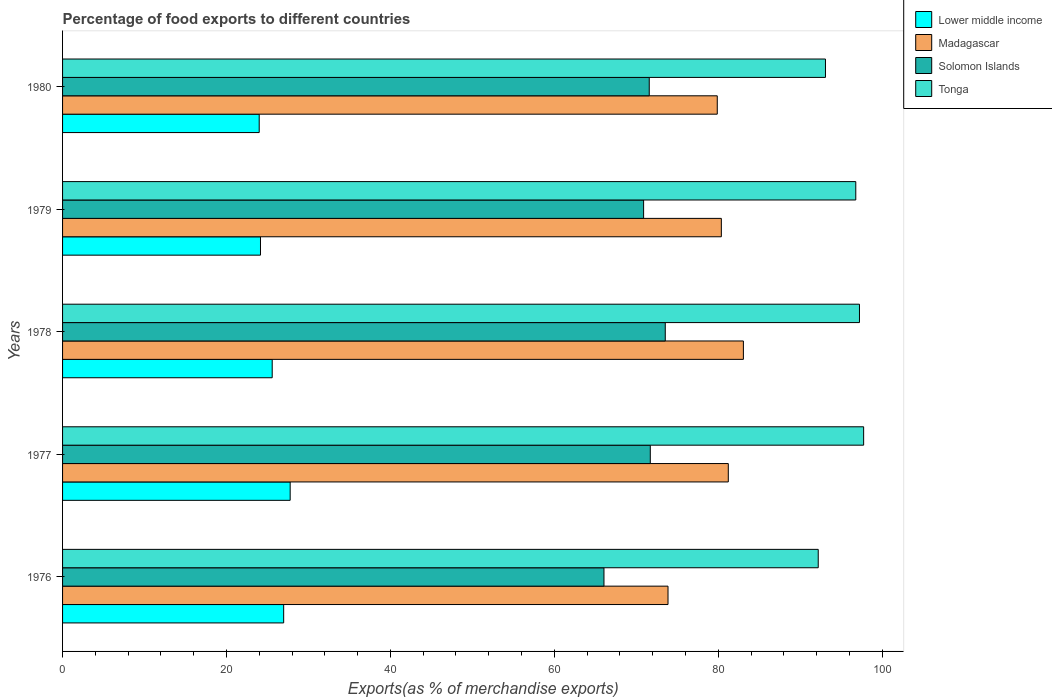How many different coloured bars are there?
Your response must be concise. 4. Are the number of bars per tick equal to the number of legend labels?
Keep it short and to the point. Yes. What is the label of the 2nd group of bars from the top?
Your answer should be very brief. 1979. What is the percentage of exports to different countries in Tonga in 1976?
Provide a succinct answer. 92.21. Across all years, what is the maximum percentage of exports to different countries in Lower middle income?
Offer a terse response. 27.77. Across all years, what is the minimum percentage of exports to different countries in Lower middle income?
Your answer should be compact. 23.99. In which year was the percentage of exports to different countries in Lower middle income minimum?
Offer a terse response. 1980. What is the total percentage of exports to different countries in Madagascar in the graph?
Offer a very short reply. 398.44. What is the difference between the percentage of exports to different countries in Madagascar in 1976 and that in 1980?
Offer a very short reply. -6.01. What is the difference between the percentage of exports to different countries in Lower middle income in 1980 and the percentage of exports to different countries in Madagascar in 1976?
Keep it short and to the point. -49.88. What is the average percentage of exports to different countries in Solomon Islands per year?
Ensure brevity in your answer.  70.76. In the year 1979, what is the difference between the percentage of exports to different countries in Madagascar and percentage of exports to different countries in Tonga?
Your response must be concise. -16.4. What is the ratio of the percentage of exports to different countries in Tonga in 1976 to that in 1977?
Your answer should be compact. 0.94. Is the percentage of exports to different countries in Lower middle income in 1979 less than that in 1980?
Offer a terse response. No. Is the difference between the percentage of exports to different countries in Madagascar in 1977 and 1980 greater than the difference between the percentage of exports to different countries in Tonga in 1977 and 1980?
Make the answer very short. No. What is the difference between the highest and the second highest percentage of exports to different countries in Tonga?
Keep it short and to the point. 0.51. What is the difference between the highest and the lowest percentage of exports to different countries in Solomon Islands?
Offer a terse response. 7.48. In how many years, is the percentage of exports to different countries in Solomon Islands greater than the average percentage of exports to different countries in Solomon Islands taken over all years?
Your answer should be very brief. 4. Is the sum of the percentage of exports to different countries in Madagascar in 1977 and 1980 greater than the maximum percentage of exports to different countries in Solomon Islands across all years?
Offer a very short reply. Yes. Is it the case that in every year, the sum of the percentage of exports to different countries in Tonga and percentage of exports to different countries in Solomon Islands is greater than the sum of percentage of exports to different countries in Madagascar and percentage of exports to different countries in Lower middle income?
Provide a short and direct response. No. What does the 1st bar from the top in 1980 represents?
Your response must be concise. Tonga. What does the 3rd bar from the bottom in 1976 represents?
Your response must be concise. Solomon Islands. Is it the case that in every year, the sum of the percentage of exports to different countries in Solomon Islands and percentage of exports to different countries in Lower middle income is greater than the percentage of exports to different countries in Tonga?
Your answer should be compact. No. Are all the bars in the graph horizontal?
Your answer should be compact. Yes. What is the difference between two consecutive major ticks on the X-axis?
Provide a short and direct response. 20. Does the graph contain any zero values?
Ensure brevity in your answer.  No. Does the graph contain grids?
Your response must be concise. No. How are the legend labels stacked?
Give a very brief answer. Vertical. What is the title of the graph?
Make the answer very short. Percentage of food exports to different countries. Does "Andorra" appear as one of the legend labels in the graph?
Your answer should be very brief. No. What is the label or title of the X-axis?
Make the answer very short. Exports(as % of merchandise exports). What is the label or title of the Y-axis?
Provide a succinct answer. Years. What is the Exports(as % of merchandise exports) of Lower middle income in 1976?
Your answer should be very brief. 26.98. What is the Exports(as % of merchandise exports) of Madagascar in 1976?
Provide a short and direct response. 73.87. What is the Exports(as % of merchandise exports) in Solomon Islands in 1976?
Your response must be concise. 66.06. What is the Exports(as % of merchandise exports) in Tonga in 1976?
Your answer should be very brief. 92.21. What is the Exports(as % of merchandise exports) in Lower middle income in 1977?
Keep it short and to the point. 27.77. What is the Exports(as % of merchandise exports) in Madagascar in 1977?
Make the answer very short. 81.23. What is the Exports(as % of merchandise exports) of Solomon Islands in 1977?
Your response must be concise. 71.71. What is the Exports(as % of merchandise exports) in Tonga in 1977?
Ensure brevity in your answer.  97.75. What is the Exports(as % of merchandise exports) in Lower middle income in 1978?
Offer a terse response. 25.58. What is the Exports(as % of merchandise exports) in Madagascar in 1978?
Provide a succinct answer. 83.07. What is the Exports(as % of merchandise exports) of Solomon Islands in 1978?
Offer a very short reply. 73.54. What is the Exports(as % of merchandise exports) in Tonga in 1978?
Give a very brief answer. 97.24. What is the Exports(as % of merchandise exports) of Lower middle income in 1979?
Ensure brevity in your answer.  24.15. What is the Exports(as % of merchandise exports) of Madagascar in 1979?
Ensure brevity in your answer.  80.38. What is the Exports(as % of merchandise exports) of Solomon Islands in 1979?
Offer a very short reply. 70.9. What is the Exports(as % of merchandise exports) in Tonga in 1979?
Make the answer very short. 96.79. What is the Exports(as % of merchandise exports) in Lower middle income in 1980?
Your answer should be compact. 23.99. What is the Exports(as % of merchandise exports) of Madagascar in 1980?
Your response must be concise. 79.89. What is the Exports(as % of merchandise exports) of Solomon Islands in 1980?
Your answer should be compact. 71.59. What is the Exports(as % of merchandise exports) of Tonga in 1980?
Your answer should be compact. 93.09. Across all years, what is the maximum Exports(as % of merchandise exports) in Lower middle income?
Make the answer very short. 27.77. Across all years, what is the maximum Exports(as % of merchandise exports) in Madagascar?
Keep it short and to the point. 83.07. Across all years, what is the maximum Exports(as % of merchandise exports) of Solomon Islands?
Your response must be concise. 73.54. Across all years, what is the maximum Exports(as % of merchandise exports) of Tonga?
Provide a succinct answer. 97.75. Across all years, what is the minimum Exports(as % of merchandise exports) in Lower middle income?
Your response must be concise. 23.99. Across all years, what is the minimum Exports(as % of merchandise exports) of Madagascar?
Give a very brief answer. 73.87. Across all years, what is the minimum Exports(as % of merchandise exports) in Solomon Islands?
Offer a terse response. 66.06. Across all years, what is the minimum Exports(as % of merchandise exports) in Tonga?
Your response must be concise. 92.21. What is the total Exports(as % of merchandise exports) of Lower middle income in the graph?
Offer a very short reply. 128.47. What is the total Exports(as % of merchandise exports) in Madagascar in the graph?
Your answer should be compact. 398.44. What is the total Exports(as % of merchandise exports) of Solomon Islands in the graph?
Your response must be concise. 353.8. What is the total Exports(as % of merchandise exports) in Tonga in the graph?
Provide a short and direct response. 477.06. What is the difference between the Exports(as % of merchandise exports) in Lower middle income in 1976 and that in 1977?
Ensure brevity in your answer.  -0.79. What is the difference between the Exports(as % of merchandise exports) in Madagascar in 1976 and that in 1977?
Offer a terse response. -7.36. What is the difference between the Exports(as % of merchandise exports) of Solomon Islands in 1976 and that in 1977?
Keep it short and to the point. -5.65. What is the difference between the Exports(as % of merchandise exports) in Tonga in 1976 and that in 1977?
Provide a succinct answer. -5.54. What is the difference between the Exports(as % of merchandise exports) of Lower middle income in 1976 and that in 1978?
Offer a very short reply. 1.4. What is the difference between the Exports(as % of merchandise exports) of Madagascar in 1976 and that in 1978?
Your response must be concise. -9.2. What is the difference between the Exports(as % of merchandise exports) in Solomon Islands in 1976 and that in 1978?
Provide a short and direct response. -7.48. What is the difference between the Exports(as % of merchandise exports) of Tonga in 1976 and that in 1978?
Give a very brief answer. -5.03. What is the difference between the Exports(as % of merchandise exports) of Lower middle income in 1976 and that in 1979?
Offer a terse response. 2.83. What is the difference between the Exports(as % of merchandise exports) of Madagascar in 1976 and that in 1979?
Provide a short and direct response. -6.51. What is the difference between the Exports(as % of merchandise exports) of Solomon Islands in 1976 and that in 1979?
Give a very brief answer. -4.84. What is the difference between the Exports(as % of merchandise exports) in Tonga in 1976 and that in 1979?
Keep it short and to the point. -4.58. What is the difference between the Exports(as % of merchandise exports) in Lower middle income in 1976 and that in 1980?
Offer a terse response. 2.99. What is the difference between the Exports(as % of merchandise exports) of Madagascar in 1976 and that in 1980?
Your response must be concise. -6.01. What is the difference between the Exports(as % of merchandise exports) in Solomon Islands in 1976 and that in 1980?
Your answer should be very brief. -5.52. What is the difference between the Exports(as % of merchandise exports) of Tonga in 1976 and that in 1980?
Provide a succinct answer. -0.88. What is the difference between the Exports(as % of merchandise exports) of Lower middle income in 1977 and that in 1978?
Make the answer very short. 2.19. What is the difference between the Exports(as % of merchandise exports) in Madagascar in 1977 and that in 1978?
Make the answer very short. -1.84. What is the difference between the Exports(as % of merchandise exports) in Solomon Islands in 1977 and that in 1978?
Keep it short and to the point. -1.83. What is the difference between the Exports(as % of merchandise exports) in Tonga in 1977 and that in 1978?
Offer a very short reply. 0.51. What is the difference between the Exports(as % of merchandise exports) of Lower middle income in 1977 and that in 1979?
Give a very brief answer. 3.62. What is the difference between the Exports(as % of merchandise exports) in Madagascar in 1977 and that in 1979?
Provide a succinct answer. 0.85. What is the difference between the Exports(as % of merchandise exports) of Solomon Islands in 1977 and that in 1979?
Offer a very short reply. 0.82. What is the difference between the Exports(as % of merchandise exports) of Tonga in 1977 and that in 1979?
Ensure brevity in your answer.  0.96. What is the difference between the Exports(as % of merchandise exports) of Lower middle income in 1977 and that in 1980?
Ensure brevity in your answer.  3.78. What is the difference between the Exports(as % of merchandise exports) of Madagascar in 1977 and that in 1980?
Your answer should be compact. 1.34. What is the difference between the Exports(as % of merchandise exports) of Solomon Islands in 1977 and that in 1980?
Your answer should be compact. 0.13. What is the difference between the Exports(as % of merchandise exports) of Tonga in 1977 and that in 1980?
Your response must be concise. 4.66. What is the difference between the Exports(as % of merchandise exports) of Lower middle income in 1978 and that in 1979?
Your answer should be very brief. 1.43. What is the difference between the Exports(as % of merchandise exports) in Madagascar in 1978 and that in 1979?
Keep it short and to the point. 2.69. What is the difference between the Exports(as % of merchandise exports) of Solomon Islands in 1978 and that in 1979?
Your answer should be very brief. 2.64. What is the difference between the Exports(as % of merchandise exports) in Tonga in 1978 and that in 1979?
Provide a succinct answer. 0.45. What is the difference between the Exports(as % of merchandise exports) of Lower middle income in 1978 and that in 1980?
Your answer should be very brief. 1.59. What is the difference between the Exports(as % of merchandise exports) in Madagascar in 1978 and that in 1980?
Give a very brief answer. 3.19. What is the difference between the Exports(as % of merchandise exports) of Solomon Islands in 1978 and that in 1980?
Your answer should be compact. 1.95. What is the difference between the Exports(as % of merchandise exports) of Tonga in 1978 and that in 1980?
Your answer should be compact. 4.15. What is the difference between the Exports(as % of merchandise exports) in Lower middle income in 1979 and that in 1980?
Ensure brevity in your answer.  0.16. What is the difference between the Exports(as % of merchandise exports) of Madagascar in 1979 and that in 1980?
Offer a very short reply. 0.5. What is the difference between the Exports(as % of merchandise exports) of Solomon Islands in 1979 and that in 1980?
Ensure brevity in your answer.  -0.69. What is the difference between the Exports(as % of merchandise exports) in Tonga in 1979 and that in 1980?
Offer a very short reply. 3.7. What is the difference between the Exports(as % of merchandise exports) of Lower middle income in 1976 and the Exports(as % of merchandise exports) of Madagascar in 1977?
Give a very brief answer. -54.25. What is the difference between the Exports(as % of merchandise exports) in Lower middle income in 1976 and the Exports(as % of merchandise exports) in Solomon Islands in 1977?
Give a very brief answer. -44.73. What is the difference between the Exports(as % of merchandise exports) of Lower middle income in 1976 and the Exports(as % of merchandise exports) of Tonga in 1977?
Offer a very short reply. -70.77. What is the difference between the Exports(as % of merchandise exports) in Madagascar in 1976 and the Exports(as % of merchandise exports) in Solomon Islands in 1977?
Your answer should be very brief. 2.16. What is the difference between the Exports(as % of merchandise exports) of Madagascar in 1976 and the Exports(as % of merchandise exports) of Tonga in 1977?
Your answer should be compact. -23.87. What is the difference between the Exports(as % of merchandise exports) in Solomon Islands in 1976 and the Exports(as % of merchandise exports) in Tonga in 1977?
Make the answer very short. -31.68. What is the difference between the Exports(as % of merchandise exports) in Lower middle income in 1976 and the Exports(as % of merchandise exports) in Madagascar in 1978?
Give a very brief answer. -56.09. What is the difference between the Exports(as % of merchandise exports) of Lower middle income in 1976 and the Exports(as % of merchandise exports) of Solomon Islands in 1978?
Provide a short and direct response. -46.56. What is the difference between the Exports(as % of merchandise exports) of Lower middle income in 1976 and the Exports(as % of merchandise exports) of Tonga in 1978?
Your answer should be compact. -70.26. What is the difference between the Exports(as % of merchandise exports) of Madagascar in 1976 and the Exports(as % of merchandise exports) of Solomon Islands in 1978?
Provide a short and direct response. 0.34. What is the difference between the Exports(as % of merchandise exports) in Madagascar in 1976 and the Exports(as % of merchandise exports) in Tonga in 1978?
Your answer should be compact. -23.36. What is the difference between the Exports(as % of merchandise exports) of Solomon Islands in 1976 and the Exports(as % of merchandise exports) of Tonga in 1978?
Your answer should be very brief. -31.18. What is the difference between the Exports(as % of merchandise exports) of Lower middle income in 1976 and the Exports(as % of merchandise exports) of Madagascar in 1979?
Ensure brevity in your answer.  -53.4. What is the difference between the Exports(as % of merchandise exports) in Lower middle income in 1976 and the Exports(as % of merchandise exports) in Solomon Islands in 1979?
Provide a short and direct response. -43.92. What is the difference between the Exports(as % of merchandise exports) of Lower middle income in 1976 and the Exports(as % of merchandise exports) of Tonga in 1979?
Give a very brief answer. -69.81. What is the difference between the Exports(as % of merchandise exports) of Madagascar in 1976 and the Exports(as % of merchandise exports) of Solomon Islands in 1979?
Your answer should be compact. 2.98. What is the difference between the Exports(as % of merchandise exports) in Madagascar in 1976 and the Exports(as % of merchandise exports) in Tonga in 1979?
Give a very brief answer. -22.91. What is the difference between the Exports(as % of merchandise exports) in Solomon Islands in 1976 and the Exports(as % of merchandise exports) in Tonga in 1979?
Your answer should be compact. -30.73. What is the difference between the Exports(as % of merchandise exports) in Lower middle income in 1976 and the Exports(as % of merchandise exports) in Madagascar in 1980?
Your answer should be very brief. -52.91. What is the difference between the Exports(as % of merchandise exports) in Lower middle income in 1976 and the Exports(as % of merchandise exports) in Solomon Islands in 1980?
Ensure brevity in your answer.  -44.61. What is the difference between the Exports(as % of merchandise exports) in Lower middle income in 1976 and the Exports(as % of merchandise exports) in Tonga in 1980?
Keep it short and to the point. -66.11. What is the difference between the Exports(as % of merchandise exports) in Madagascar in 1976 and the Exports(as % of merchandise exports) in Solomon Islands in 1980?
Make the answer very short. 2.29. What is the difference between the Exports(as % of merchandise exports) in Madagascar in 1976 and the Exports(as % of merchandise exports) in Tonga in 1980?
Provide a short and direct response. -19.21. What is the difference between the Exports(as % of merchandise exports) in Solomon Islands in 1976 and the Exports(as % of merchandise exports) in Tonga in 1980?
Your response must be concise. -27.03. What is the difference between the Exports(as % of merchandise exports) of Lower middle income in 1977 and the Exports(as % of merchandise exports) of Madagascar in 1978?
Your answer should be compact. -55.3. What is the difference between the Exports(as % of merchandise exports) of Lower middle income in 1977 and the Exports(as % of merchandise exports) of Solomon Islands in 1978?
Provide a short and direct response. -45.77. What is the difference between the Exports(as % of merchandise exports) of Lower middle income in 1977 and the Exports(as % of merchandise exports) of Tonga in 1978?
Provide a short and direct response. -69.46. What is the difference between the Exports(as % of merchandise exports) in Madagascar in 1977 and the Exports(as % of merchandise exports) in Solomon Islands in 1978?
Give a very brief answer. 7.69. What is the difference between the Exports(as % of merchandise exports) of Madagascar in 1977 and the Exports(as % of merchandise exports) of Tonga in 1978?
Give a very brief answer. -16.01. What is the difference between the Exports(as % of merchandise exports) of Solomon Islands in 1977 and the Exports(as % of merchandise exports) of Tonga in 1978?
Offer a terse response. -25.52. What is the difference between the Exports(as % of merchandise exports) of Lower middle income in 1977 and the Exports(as % of merchandise exports) of Madagascar in 1979?
Your response must be concise. -52.61. What is the difference between the Exports(as % of merchandise exports) in Lower middle income in 1977 and the Exports(as % of merchandise exports) in Solomon Islands in 1979?
Offer a very short reply. -43.13. What is the difference between the Exports(as % of merchandise exports) of Lower middle income in 1977 and the Exports(as % of merchandise exports) of Tonga in 1979?
Ensure brevity in your answer.  -69.02. What is the difference between the Exports(as % of merchandise exports) in Madagascar in 1977 and the Exports(as % of merchandise exports) in Solomon Islands in 1979?
Keep it short and to the point. 10.33. What is the difference between the Exports(as % of merchandise exports) of Madagascar in 1977 and the Exports(as % of merchandise exports) of Tonga in 1979?
Your response must be concise. -15.56. What is the difference between the Exports(as % of merchandise exports) of Solomon Islands in 1977 and the Exports(as % of merchandise exports) of Tonga in 1979?
Provide a succinct answer. -25.07. What is the difference between the Exports(as % of merchandise exports) in Lower middle income in 1977 and the Exports(as % of merchandise exports) in Madagascar in 1980?
Provide a succinct answer. -52.11. What is the difference between the Exports(as % of merchandise exports) of Lower middle income in 1977 and the Exports(as % of merchandise exports) of Solomon Islands in 1980?
Your answer should be very brief. -43.81. What is the difference between the Exports(as % of merchandise exports) of Lower middle income in 1977 and the Exports(as % of merchandise exports) of Tonga in 1980?
Give a very brief answer. -65.32. What is the difference between the Exports(as % of merchandise exports) in Madagascar in 1977 and the Exports(as % of merchandise exports) in Solomon Islands in 1980?
Provide a succinct answer. 9.64. What is the difference between the Exports(as % of merchandise exports) in Madagascar in 1977 and the Exports(as % of merchandise exports) in Tonga in 1980?
Make the answer very short. -11.86. What is the difference between the Exports(as % of merchandise exports) of Solomon Islands in 1977 and the Exports(as % of merchandise exports) of Tonga in 1980?
Offer a very short reply. -21.37. What is the difference between the Exports(as % of merchandise exports) of Lower middle income in 1978 and the Exports(as % of merchandise exports) of Madagascar in 1979?
Offer a very short reply. -54.8. What is the difference between the Exports(as % of merchandise exports) in Lower middle income in 1978 and the Exports(as % of merchandise exports) in Solomon Islands in 1979?
Keep it short and to the point. -45.32. What is the difference between the Exports(as % of merchandise exports) in Lower middle income in 1978 and the Exports(as % of merchandise exports) in Tonga in 1979?
Keep it short and to the point. -71.21. What is the difference between the Exports(as % of merchandise exports) of Madagascar in 1978 and the Exports(as % of merchandise exports) of Solomon Islands in 1979?
Offer a very short reply. 12.17. What is the difference between the Exports(as % of merchandise exports) in Madagascar in 1978 and the Exports(as % of merchandise exports) in Tonga in 1979?
Your answer should be compact. -13.71. What is the difference between the Exports(as % of merchandise exports) in Solomon Islands in 1978 and the Exports(as % of merchandise exports) in Tonga in 1979?
Provide a short and direct response. -23.25. What is the difference between the Exports(as % of merchandise exports) in Lower middle income in 1978 and the Exports(as % of merchandise exports) in Madagascar in 1980?
Your answer should be very brief. -54.31. What is the difference between the Exports(as % of merchandise exports) of Lower middle income in 1978 and the Exports(as % of merchandise exports) of Solomon Islands in 1980?
Provide a succinct answer. -46. What is the difference between the Exports(as % of merchandise exports) of Lower middle income in 1978 and the Exports(as % of merchandise exports) of Tonga in 1980?
Your answer should be compact. -67.51. What is the difference between the Exports(as % of merchandise exports) in Madagascar in 1978 and the Exports(as % of merchandise exports) in Solomon Islands in 1980?
Ensure brevity in your answer.  11.49. What is the difference between the Exports(as % of merchandise exports) in Madagascar in 1978 and the Exports(as % of merchandise exports) in Tonga in 1980?
Your answer should be very brief. -10.02. What is the difference between the Exports(as % of merchandise exports) of Solomon Islands in 1978 and the Exports(as % of merchandise exports) of Tonga in 1980?
Keep it short and to the point. -19.55. What is the difference between the Exports(as % of merchandise exports) in Lower middle income in 1979 and the Exports(as % of merchandise exports) in Madagascar in 1980?
Offer a terse response. -55.74. What is the difference between the Exports(as % of merchandise exports) in Lower middle income in 1979 and the Exports(as % of merchandise exports) in Solomon Islands in 1980?
Your answer should be compact. -47.44. What is the difference between the Exports(as % of merchandise exports) of Lower middle income in 1979 and the Exports(as % of merchandise exports) of Tonga in 1980?
Ensure brevity in your answer.  -68.94. What is the difference between the Exports(as % of merchandise exports) of Madagascar in 1979 and the Exports(as % of merchandise exports) of Solomon Islands in 1980?
Your response must be concise. 8.8. What is the difference between the Exports(as % of merchandise exports) of Madagascar in 1979 and the Exports(as % of merchandise exports) of Tonga in 1980?
Give a very brief answer. -12.71. What is the difference between the Exports(as % of merchandise exports) in Solomon Islands in 1979 and the Exports(as % of merchandise exports) in Tonga in 1980?
Your response must be concise. -22.19. What is the average Exports(as % of merchandise exports) in Lower middle income per year?
Your answer should be compact. 25.69. What is the average Exports(as % of merchandise exports) in Madagascar per year?
Your answer should be compact. 79.69. What is the average Exports(as % of merchandise exports) of Solomon Islands per year?
Offer a very short reply. 70.76. What is the average Exports(as % of merchandise exports) of Tonga per year?
Keep it short and to the point. 95.41. In the year 1976, what is the difference between the Exports(as % of merchandise exports) of Lower middle income and Exports(as % of merchandise exports) of Madagascar?
Provide a short and direct response. -46.9. In the year 1976, what is the difference between the Exports(as % of merchandise exports) of Lower middle income and Exports(as % of merchandise exports) of Solomon Islands?
Keep it short and to the point. -39.08. In the year 1976, what is the difference between the Exports(as % of merchandise exports) in Lower middle income and Exports(as % of merchandise exports) in Tonga?
Make the answer very short. -65.23. In the year 1976, what is the difference between the Exports(as % of merchandise exports) of Madagascar and Exports(as % of merchandise exports) of Solomon Islands?
Your response must be concise. 7.81. In the year 1976, what is the difference between the Exports(as % of merchandise exports) of Madagascar and Exports(as % of merchandise exports) of Tonga?
Keep it short and to the point. -18.33. In the year 1976, what is the difference between the Exports(as % of merchandise exports) in Solomon Islands and Exports(as % of merchandise exports) in Tonga?
Your response must be concise. -26.15. In the year 1977, what is the difference between the Exports(as % of merchandise exports) in Lower middle income and Exports(as % of merchandise exports) in Madagascar?
Offer a terse response. -53.46. In the year 1977, what is the difference between the Exports(as % of merchandise exports) in Lower middle income and Exports(as % of merchandise exports) in Solomon Islands?
Your answer should be very brief. -43.94. In the year 1977, what is the difference between the Exports(as % of merchandise exports) of Lower middle income and Exports(as % of merchandise exports) of Tonga?
Provide a succinct answer. -69.97. In the year 1977, what is the difference between the Exports(as % of merchandise exports) in Madagascar and Exports(as % of merchandise exports) in Solomon Islands?
Your response must be concise. 9.52. In the year 1977, what is the difference between the Exports(as % of merchandise exports) in Madagascar and Exports(as % of merchandise exports) in Tonga?
Your answer should be very brief. -16.52. In the year 1977, what is the difference between the Exports(as % of merchandise exports) of Solomon Islands and Exports(as % of merchandise exports) of Tonga?
Your response must be concise. -26.03. In the year 1978, what is the difference between the Exports(as % of merchandise exports) of Lower middle income and Exports(as % of merchandise exports) of Madagascar?
Offer a terse response. -57.49. In the year 1978, what is the difference between the Exports(as % of merchandise exports) of Lower middle income and Exports(as % of merchandise exports) of Solomon Islands?
Make the answer very short. -47.96. In the year 1978, what is the difference between the Exports(as % of merchandise exports) of Lower middle income and Exports(as % of merchandise exports) of Tonga?
Keep it short and to the point. -71.66. In the year 1978, what is the difference between the Exports(as % of merchandise exports) in Madagascar and Exports(as % of merchandise exports) in Solomon Islands?
Ensure brevity in your answer.  9.53. In the year 1978, what is the difference between the Exports(as % of merchandise exports) in Madagascar and Exports(as % of merchandise exports) in Tonga?
Ensure brevity in your answer.  -14.16. In the year 1978, what is the difference between the Exports(as % of merchandise exports) in Solomon Islands and Exports(as % of merchandise exports) in Tonga?
Offer a terse response. -23.7. In the year 1979, what is the difference between the Exports(as % of merchandise exports) in Lower middle income and Exports(as % of merchandise exports) in Madagascar?
Keep it short and to the point. -56.23. In the year 1979, what is the difference between the Exports(as % of merchandise exports) of Lower middle income and Exports(as % of merchandise exports) of Solomon Islands?
Give a very brief answer. -46.75. In the year 1979, what is the difference between the Exports(as % of merchandise exports) of Lower middle income and Exports(as % of merchandise exports) of Tonga?
Offer a terse response. -72.64. In the year 1979, what is the difference between the Exports(as % of merchandise exports) of Madagascar and Exports(as % of merchandise exports) of Solomon Islands?
Provide a succinct answer. 9.48. In the year 1979, what is the difference between the Exports(as % of merchandise exports) in Madagascar and Exports(as % of merchandise exports) in Tonga?
Ensure brevity in your answer.  -16.4. In the year 1979, what is the difference between the Exports(as % of merchandise exports) of Solomon Islands and Exports(as % of merchandise exports) of Tonga?
Your response must be concise. -25.89. In the year 1980, what is the difference between the Exports(as % of merchandise exports) in Lower middle income and Exports(as % of merchandise exports) in Madagascar?
Offer a terse response. -55.89. In the year 1980, what is the difference between the Exports(as % of merchandise exports) of Lower middle income and Exports(as % of merchandise exports) of Solomon Islands?
Your answer should be very brief. -47.59. In the year 1980, what is the difference between the Exports(as % of merchandise exports) of Lower middle income and Exports(as % of merchandise exports) of Tonga?
Provide a succinct answer. -69.09. In the year 1980, what is the difference between the Exports(as % of merchandise exports) in Madagascar and Exports(as % of merchandise exports) in Solomon Islands?
Provide a short and direct response. 8.3. In the year 1980, what is the difference between the Exports(as % of merchandise exports) in Madagascar and Exports(as % of merchandise exports) in Tonga?
Provide a succinct answer. -13.2. In the year 1980, what is the difference between the Exports(as % of merchandise exports) of Solomon Islands and Exports(as % of merchandise exports) of Tonga?
Your answer should be very brief. -21.5. What is the ratio of the Exports(as % of merchandise exports) of Lower middle income in 1976 to that in 1977?
Offer a terse response. 0.97. What is the ratio of the Exports(as % of merchandise exports) in Madagascar in 1976 to that in 1977?
Make the answer very short. 0.91. What is the ratio of the Exports(as % of merchandise exports) of Solomon Islands in 1976 to that in 1977?
Your response must be concise. 0.92. What is the ratio of the Exports(as % of merchandise exports) of Tonga in 1976 to that in 1977?
Give a very brief answer. 0.94. What is the ratio of the Exports(as % of merchandise exports) in Lower middle income in 1976 to that in 1978?
Offer a terse response. 1.05. What is the ratio of the Exports(as % of merchandise exports) of Madagascar in 1976 to that in 1978?
Give a very brief answer. 0.89. What is the ratio of the Exports(as % of merchandise exports) of Solomon Islands in 1976 to that in 1978?
Provide a succinct answer. 0.9. What is the ratio of the Exports(as % of merchandise exports) of Tonga in 1976 to that in 1978?
Your answer should be very brief. 0.95. What is the ratio of the Exports(as % of merchandise exports) in Lower middle income in 1976 to that in 1979?
Make the answer very short. 1.12. What is the ratio of the Exports(as % of merchandise exports) in Madagascar in 1976 to that in 1979?
Provide a short and direct response. 0.92. What is the ratio of the Exports(as % of merchandise exports) in Solomon Islands in 1976 to that in 1979?
Your answer should be compact. 0.93. What is the ratio of the Exports(as % of merchandise exports) of Tonga in 1976 to that in 1979?
Make the answer very short. 0.95. What is the ratio of the Exports(as % of merchandise exports) of Lower middle income in 1976 to that in 1980?
Give a very brief answer. 1.12. What is the ratio of the Exports(as % of merchandise exports) in Madagascar in 1976 to that in 1980?
Your response must be concise. 0.92. What is the ratio of the Exports(as % of merchandise exports) in Solomon Islands in 1976 to that in 1980?
Provide a succinct answer. 0.92. What is the ratio of the Exports(as % of merchandise exports) in Lower middle income in 1977 to that in 1978?
Give a very brief answer. 1.09. What is the ratio of the Exports(as % of merchandise exports) in Madagascar in 1977 to that in 1978?
Provide a short and direct response. 0.98. What is the ratio of the Exports(as % of merchandise exports) in Solomon Islands in 1977 to that in 1978?
Keep it short and to the point. 0.98. What is the ratio of the Exports(as % of merchandise exports) in Tonga in 1977 to that in 1978?
Your response must be concise. 1.01. What is the ratio of the Exports(as % of merchandise exports) of Lower middle income in 1977 to that in 1979?
Ensure brevity in your answer.  1.15. What is the ratio of the Exports(as % of merchandise exports) in Madagascar in 1977 to that in 1979?
Offer a terse response. 1.01. What is the ratio of the Exports(as % of merchandise exports) in Solomon Islands in 1977 to that in 1979?
Your response must be concise. 1.01. What is the ratio of the Exports(as % of merchandise exports) in Tonga in 1977 to that in 1979?
Provide a succinct answer. 1.01. What is the ratio of the Exports(as % of merchandise exports) in Lower middle income in 1977 to that in 1980?
Keep it short and to the point. 1.16. What is the ratio of the Exports(as % of merchandise exports) in Madagascar in 1977 to that in 1980?
Offer a terse response. 1.02. What is the ratio of the Exports(as % of merchandise exports) in Tonga in 1977 to that in 1980?
Give a very brief answer. 1.05. What is the ratio of the Exports(as % of merchandise exports) of Lower middle income in 1978 to that in 1979?
Offer a terse response. 1.06. What is the ratio of the Exports(as % of merchandise exports) of Madagascar in 1978 to that in 1979?
Your response must be concise. 1.03. What is the ratio of the Exports(as % of merchandise exports) in Solomon Islands in 1978 to that in 1979?
Provide a succinct answer. 1.04. What is the ratio of the Exports(as % of merchandise exports) in Lower middle income in 1978 to that in 1980?
Offer a very short reply. 1.07. What is the ratio of the Exports(as % of merchandise exports) in Madagascar in 1978 to that in 1980?
Your answer should be very brief. 1.04. What is the ratio of the Exports(as % of merchandise exports) of Solomon Islands in 1978 to that in 1980?
Your answer should be compact. 1.03. What is the ratio of the Exports(as % of merchandise exports) in Tonga in 1978 to that in 1980?
Offer a terse response. 1.04. What is the ratio of the Exports(as % of merchandise exports) in Madagascar in 1979 to that in 1980?
Offer a terse response. 1.01. What is the ratio of the Exports(as % of merchandise exports) in Tonga in 1979 to that in 1980?
Offer a terse response. 1.04. What is the difference between the highest and the second highest Exports(as % of merchandise exports) in Lower middle income?
Provide a short and direct response. 0.79. What is the difference between the highest and the second highest Exports(as % of merchandise exports) in Madagascar?
Your response must be concise. 1.84. What is the difference between the highest and the second highest Exports(as % of merchandise exports) of Solomon Islands?
Offer a terse response. 1.83. What is the difference between the highest and the second highest Exports(as % of merchandise exports) of Tonga?
Make the answer very short. 0.51. What is the difference between the highest and the lowest Exports(as % of merchandise exports) in Lower middle income?
Offer a very short reply. 3.78. What is the difference between the highest and the lowest Exports(as % of merchandise exports) in Madagascar?
Your response must be concise. 9.2. What is the difference between the highest and the lowest Exports(as % of merchandise exports) of Solomon Islands?
Offer a terse response. 7.48. What is the difference between the highest and the lowest Exports(as % of merchandise exports) of Tonga?
Offer a terse response. 5.54. 